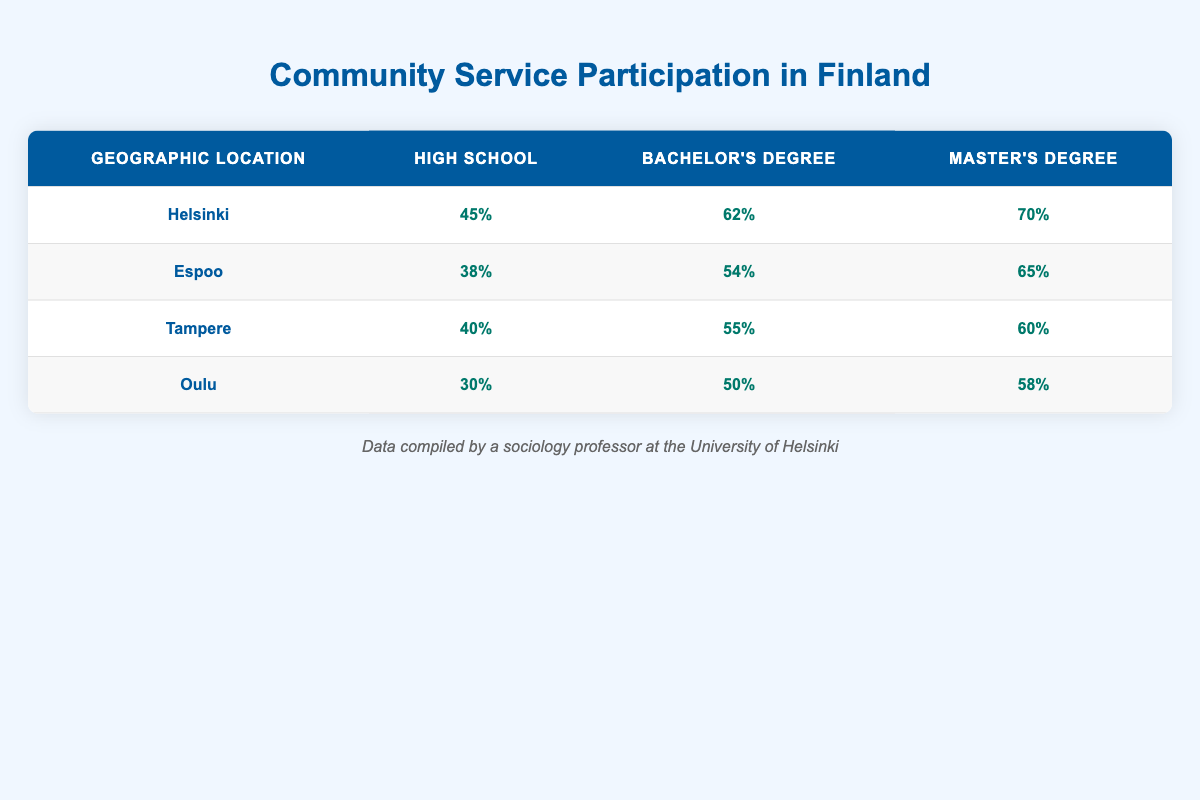What's the participation percentage for people with a Master's Degree in Helsinki? From the table, we can directly find that the participation percentage for people with a Master's Degree in Helsinki is listed under the relevant row. Specifically, it shows 70%.
Answer: 70% Which geographic location has the highest participation percentage for individuals with a Bachelor's Degree? Examining the Bachelor's Degree column, we see the following percentages: Helsinki (62%), Espoo (54%), Tampere (55%), and Oulu (50%). The highest percentage is found in Helsinki, which is 62%.
Answer: Helsinki What is the average participation percentage for High School graduates across all geographic locations? To find the average, we sum the participation percentages for High School graduates: 45 (Helsinki) + 38 (Espoo) + 40 (Tampere) + 30 (Oulu) = 153. There are 4 locations, so we divide 153 by 4 to get the average: 153 / 4 = 38.25.
Answer: 38.25 Is it true that Espoo has higher participation percentages than Oulu across all education levels? Looking at the table, we compare the percentages: for High School, Espoo (38%) is greater than Oulu (30%), for Bachelor's Degree, Espoo (54%) is greater than Oulu (50%), but for Master's Degree, Espoo (65%) is less than Oulu (58%). Therefore, the statement is false.
Answer: No How much higher is the participation percentage for Master's Degree holders in Helsinki compared to those in Oulu? We look at the percentages for Master's Degree holders: Helsinki has 70%, while Oulu has 58%. The difference is 70 - 58 = 12. Hence, Master's Degree holders in Helsinki participate 12% more than those in Oulu.
Answer: 12% 